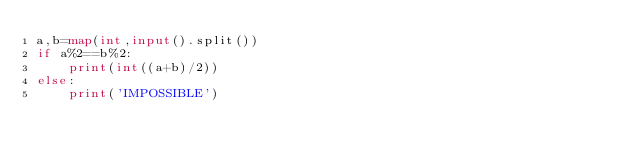<code> <loc_0><loc_0><loc_500><loc_500><_Python_>a,b=map(int,input().split())
if a%2==b%2:
    print(int((a+b)/2))
else:
    print('IMPOSSIBLE')</code> 